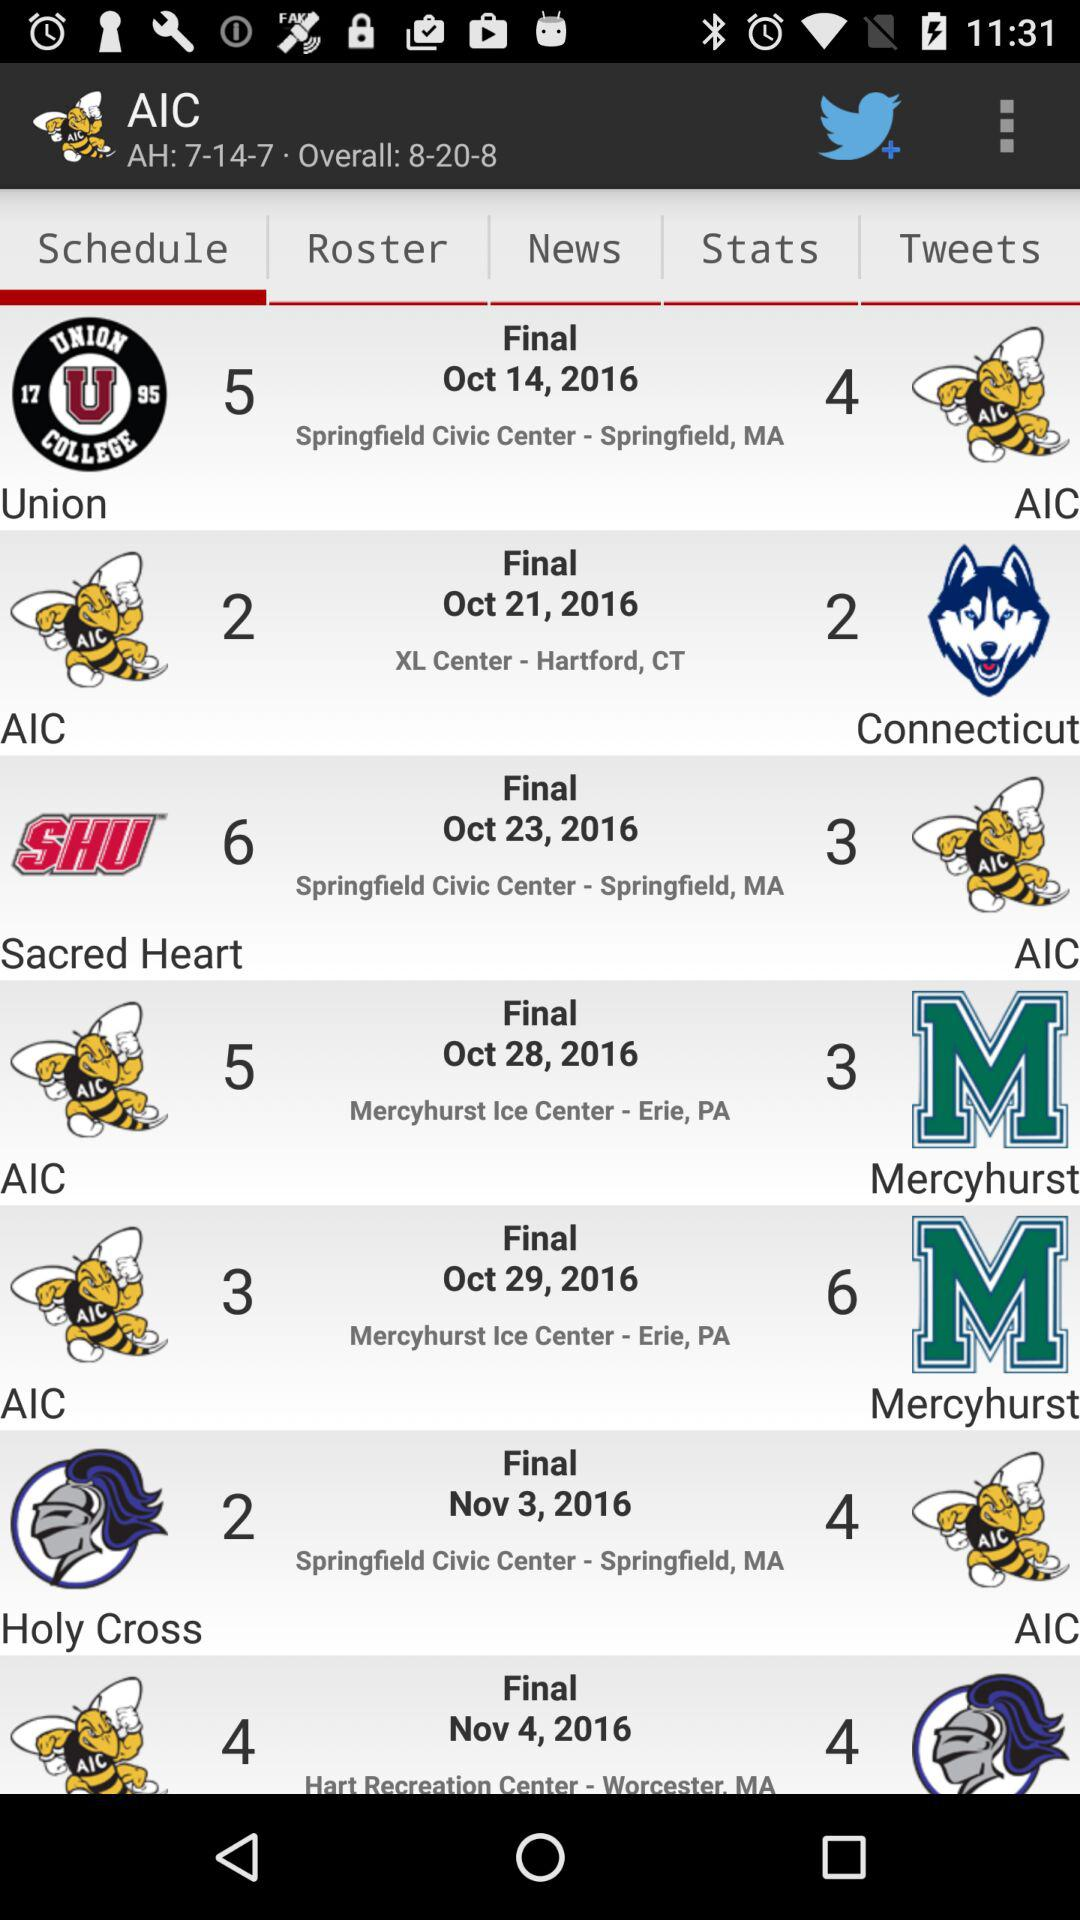How many teams are in "Roster"?
When the provided information is insufficient, respond with <no answer>. <no answer> 